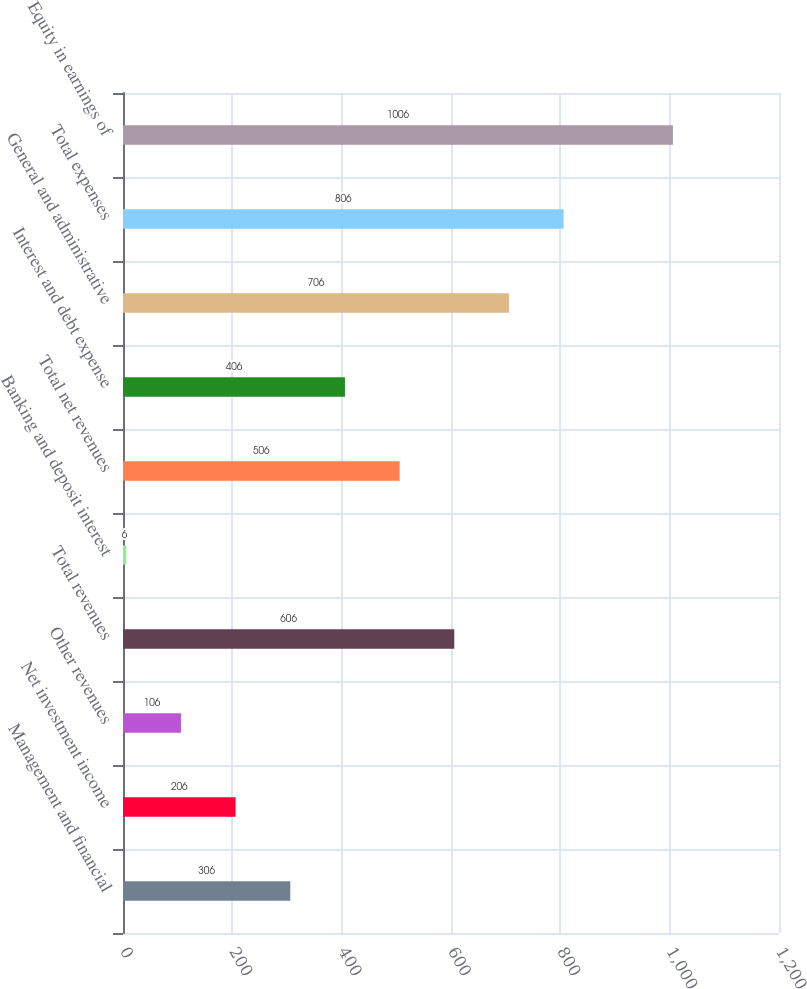Convert chart. <chart><loc_0><loc_0><loc_500><loc_500><bar_chart><fcel>Management and financial<fcel>Net investment income<fcel>Other revenues<fcel>Total revenues<fcel>Banking and deposit interest<fcel>Total net revenues<fcel>Interest and debt expense<fcel>General and administrative<fcel>Total expenses<fcel>Equity in earnings of<nl><fcel>306<fcel>206<fcel>106<fcel>606<fcel>6<fcel>506<fcel>406<fcel>706<fcel>806<fcel>1006<nl></chart> 